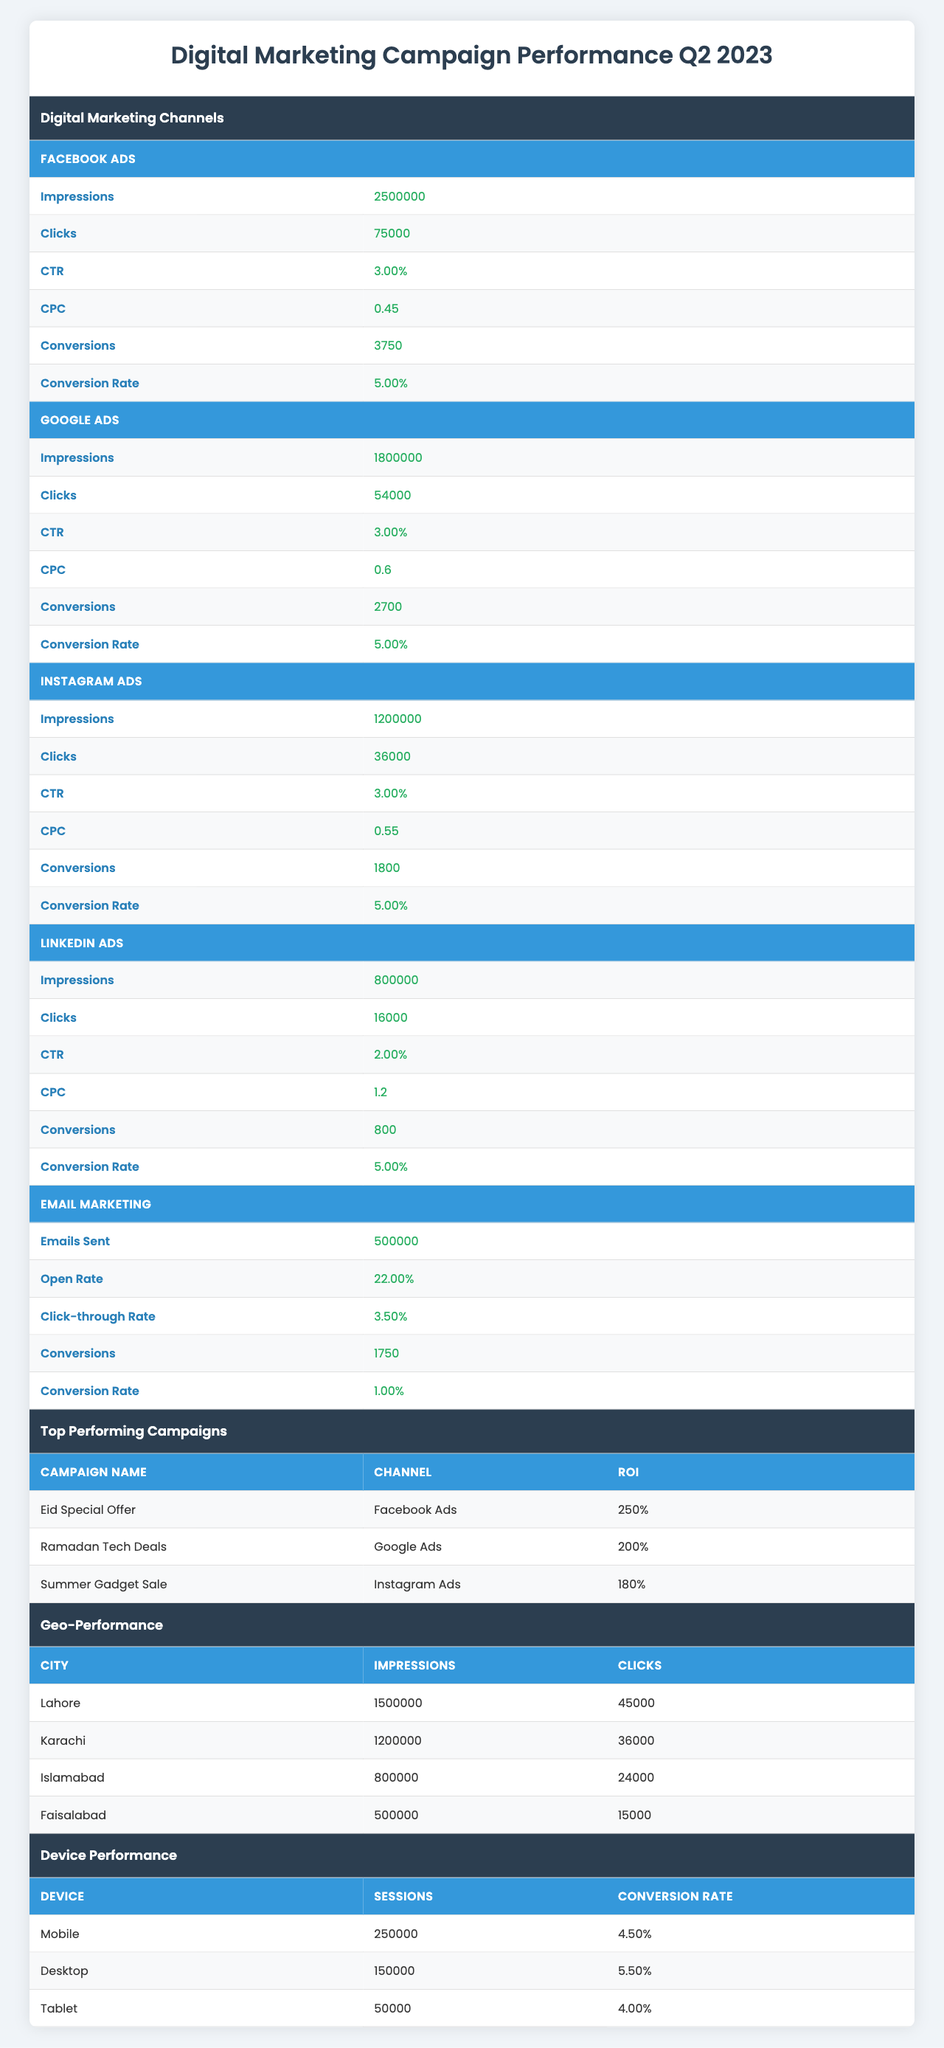What were the total conversions from Facebook Ads in Q2 2023? According to the table, Facebook Ads had 3750 conversions listed under its metrics.
Answer: 3750 What is the CTR (Click-through Rate) for Google Ads? The table shows that Google Ads has a CTR of 3.00% in its metrics section.
Answer: 3.00% Which campaign had the highest ROI, and what is its value? The campaign "Eid Special Offer" on Facebook Ads had the highest ROI, which is listed as 250%.
Answer: Eid Special Offer, 250% What was the total impressions for Instagram Ads? The table indicates that Instagram Ads had a total of 1,200,000 impressions.
Answer: 1,200,000 Is the Open Rate for Email Marketing higher than the CTR for Facebook Ads? The open rate for Email Marketing is 22.00%, while the CTR for Facebook Ads is 3.00%; since 22.00% is higher, the statement is true.
Answer: Yes What is the average conversion rate across all digital marketing channels listed in the table? The conversion rates for each channel are: Facebook Ads (5.00%), Google Ads (5.00%), Instagram Ads (5.00%), LinkedIn Ads (5.00%), and Email Marketing (1.00%). The average can be calculated as (5.00 + 5.00 + 5.00 + 5.00 + 1.00) / 5 = 21.00 / 5 = 4.20%.
Answer: 4.20% Which device had the highest average order value, and what is that value? From the Device Performance section, Desktop has the highest average order value of 100.
Answer: Desktop, 100 Based on the Geo-Performance data, which city had the highest number of clicks? The data shows Lahore had 45,000 clicks, which is higher than the clicks for other cities: Karachi (36,000), Islamabad (24,000), and Faisalabad (15,000).
Answer: Lahore What is the total spend for the top-performing campaigns listed? The total spend can be calculated by summing the spends for the top three campaigns: 5000 + 7500 + 4000 = 16500.
Answer: 16500 How does the conversion rate for mobile devices compare to that of tablets? The conversion rate for mobile devices is 4.50% while for tablets it is 4.00%. Since 4.50% is higher than 4.00%, mobile devices have a better conversion rate.
Answer: Mobile devices are higher Which city had the lowest number of conversions among the listed cities? In the Geo-Performance data, Faisalabad had the lowest number of conversions at 750, compared to Lahore (2250), Karachi (1800), and Islamabad (1200).
Answer: Faisalabad, 750 